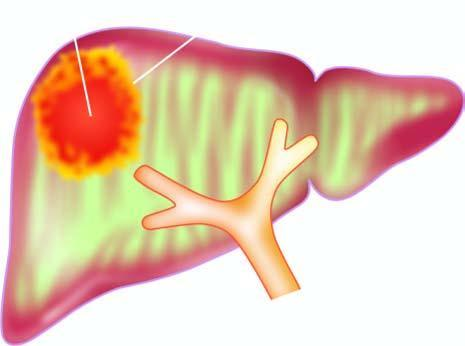s amoebic liver abscess's wall irregular and necrotic?
Answer the question using a single word or phrase. Yes 